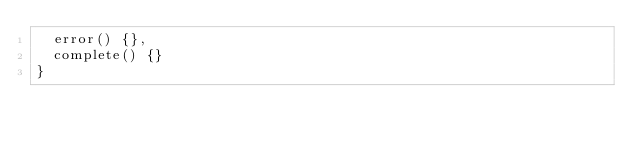<code> <loc_0><loc_0><loc_500><loc_500><_JavaScript_>  error() {},
  complete() {}
}
</code> 